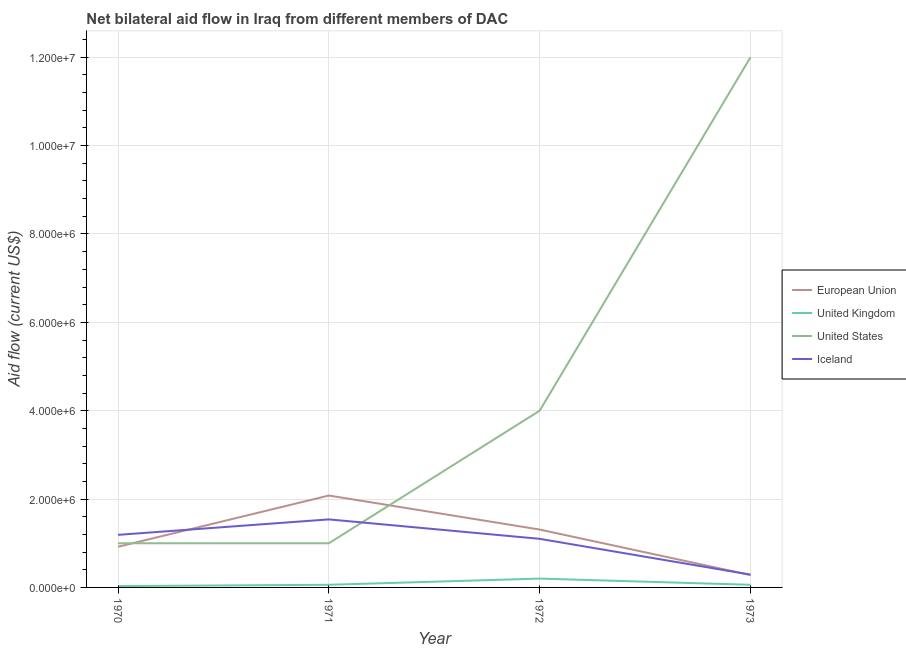Does the line corresponding to amount of aid given by eu intersect with the line corresponding to amount of aid given by uk?
Your answer should be compact. No. What is the amount of aid given by uk in 1971?
Give a very brief answer. 6.00e+04. Across all years, what is the maximum amount of aid given by iceland?
Ensure brevity in your answer.  1.54e+06. Across all years, what is the minimum amount of aid given by iceland?
Ensure brevity in your answer.  2.90e+05. What is the total amount of aid given by eu in the graph?
Your response must be concise. 4.59e+06. What is the difference between the amount of aid given by eu in 1970 and that in 1972?
Provide a short and direct response. -3.90e+05. What is the difference between the amount of aid given by iceland in 1973 and the amount of aid given by us in 1972?
Offer a very short reply. -3.71e+06. What is the average amount of aid given by eu per year?
Your response must be concise. 1.15e+06. In the year 1972, what is the difference between the amount of aid given by eu and amount of aid given by uk?
Offer a terse response. 1.11e+06. What is the ratio of the amount of aid given by us in 1971 to that in 1972?
Your answer should be compact. 0.25. Is the amount of aid given by eu in 1970 less than that in 1971?
Offer a terse response. Yes. Is the difference between the amount of aid given by iceland in 1970 and 1973 greater than the difference between the amount of aid given by eu in 1970 and 1973?
Your answer should be compact. Yes. What is the difference between the highest and the lowest amount of aid given by eu?
Your response must be concise. 1.80e+06. Is it the case that in every year, the sum of the amount of aid given by us and amount of aid given by eu is greater than the sum of amount of aid given by iceland and amount of aid given by uk?
Keep it short and to the point. Yes. Does the amount of aid given by us monotonically increase over the years?
Your answer should be very brief. No. Is the amount of aid given by uk strictly greater than the amount of aid given by eu over the years?
Provide a succinct answer. No. How many years are there in the graph?
Provide a short and direct response. 4. Does the graph contain grids?
Your response must be concise. Yes. How many legend labels are there?
Provide a succinct answer. 4. How are the legend labels stacked?
Give a very brief answer. Vertical. What is the title of the graph?
Make the answer very short. Net bilateral aid flow in Iraq from different members of DAC. What is the label or title of the X-axis?
Your answer should be compact. Year. What is the label or title of the Y-axis?
Ensure brevity in your answer.  Aid flow (current US$). What is the Aid flow (current US$) of European Union in 1970?
Offer a terse response. 9.20e+05. What is the Aid flow (current US$) of United States in 1970?
Offer a terse response. 1.00e+06. What is the Aid flow (current US$) of Iceland in 1970?
Provide a short and direct response. 1.19e+06. What is the Aid flow (current US$) in European Union in 1971?
Ensure brevity in your answer.  2.08e+06. What is the Aid flow (current US$) of United States in 1971?
Keep it short and to the point. 1.00e+06. What is the Aid flow (current US$) in Iceland in 1971?
Provide a short and direct response. 1.54e+06. What is the Aid flow (current US$) in European Union in 1972?
Keep it short and to the point. 1.31e+06. What is the Aid flow (current US$) in United Kingdom in 1972?
Provide a succinct answer. 2.00e+05. What is the Aid flow (current US$) of Iceland in 1972?
Make the answer very short. 1.10e+06. What is the Aid flow (current US$) of European Union in 1973?
Your response must be concise. 2.80e+05. What is the Aid flow (current US$) in United Kingdom in 1973?
Your answer should be compact. 6.00e+04. What is the Aid flow (current US$) of Iceland in 1973?
Provide a succinct answer. 2.90e+05. Across all years, what is the maximum Aid flow (current US$) of European Union?
Ensure brevity in your answer.  2.08e+06. Across all years, what is the maximum Aid flow (current US$) of United Kingdom?
Ensure brevity in your answer.  2.00e+05. Across all years, what is the maximum Aid flow (current US$) of United States?
Your answer should be very brief. 1.20e+07. Across all years, what is the maximum Aid flow (current US$) of Iceland?
Offer a terse response. 1.54e+06. Across all years, what is the minimum Aid flow (current US$) of European Union?
Give a very brief answer. 2.80e+05. Across all years, what is the minimum Aid flow (current US$) in United Kingdom?
Give a very brief answer. 3.00e+04. Across all years, what is the minimum Aid flow (current US$) of Iceland?
Your answer should be compact. 2.90e+05. What is the total Aid flow (current US$) in European Union in the graph?
Your response must be concise. 4.59e+06. What is the total Aid flow (current US$) in United Kingdom in the graph?
Offer a terse response. 3.50e+05. What is the total Aid flow (current US$) of United States in the graph?
Provide a short and direct response. 1.80e+07. What is the total Aid flow (current US$) in Iceland in the graph?
Give a very brief answer. 4.12e+06. What is the difference between the Aid flow (current US$) of European Union in 1970 and that in 1971?
Your answer should be very brief. -1.16e+06. What is the difference between the Aid flow (current US$) of United Kingdom in 1970 and that in 1971?
Ensure brevity in your answer.  -3.00e+04. What is the difference between the Aid flow (current US$) of Iceland in 1970 and that in 1971?
Your answer should be very brief. -3.50e+05. What is the difference between the Aid flow (current US$) of European Union in 1970 and that in 1972?
Give a very brief answer. -3.90e+05. What is the difference between the Aid flow (current US$) of Iceland in 1970 and that in 1972?
Offer a very short reply. 9.00e+04. What is the difference between the Aid flow (current US$) in European Union in 1970 and that in 1973?
Keep it short and to the point. 6.40e+05. What is the difference between the Aid flow (current US$) in United States in 1970 and that in 1973?
Ensure brevity in your answer.  -1.10e+07. What is the difference between the Aid flow (current US$) of Iceland in 1970 and that in 1973?
Keep it short and to the point. 9.00e+05. What is the difference between the Aid flow (current US$) of European Union in 1971 and that in 1972?
Ensure brevity in your answer.  7.70e+05. What is the difference between the Aid flow (current US$) in United States in 1971 and that in 1972?
Provide a succinct answer. -3.00e+06. What is the difference between the Aid flow (current US$) of Iceland in 1971 and that in 1972?
Keep it short and to the point. 4.40e+05. What is the difference between the Aid flow (current US$) in European Union in 1971 and that in 1973?
Your response must be concise. 1.80e+06. What is the difference between the Aid flow (current US$) of United States in 1971 and that in 1973?
Offer a very short reply. -1.10e+07. What is the difference between the Aid flow (current US$) of Iceland in 1971 and that in 1973?
Ensure brevity in your answer.  1.25e+06. What is the difference between the Aid flow (current US$) of European Union in 1972 and that in 1973?
Ensure brevity in your answer.  1.03e+06. What is the difference between the Aid flow (current US$) in United States in 1972 and that in 1973?
Your response must be concise. -8.00e+06. What is the difference between the Aid flow (current US$) in Iceland in 1972 and that in 1973?
Your response must be concise. 8.10e+05. What is the difference between the Aid flow (current US$) of European Union in 1970 and the Aid flow (current US$) of United Kingdom in 1971?
Your response must be concise. 8.60e+05. What is the difference between the Aid flow (current US$) in European Union in 1970 and the Aid flow (current US$) in United States in 1971?
Keep it short and to the point. -8.00e+04. What is the difference between the Aid flow (current US$) in European Union in 1970 and the Aid flow (current US$) in Iceland in 1971?
Offer a terse response. -6.20e+05. What is the difference between the Aid flow (current US$) of United Kingdom in 1970 and the Aid flow (current US$) of United States in 1971?
Ensure brevity in your answer.  -9.70e+05. What is the difference between the Aid flow (current US$) in United Kingdom in 1970 and the Aid flow (current US$) in Iceland in 1971?
Your response must be concise. -1.51e+06. What is the difference between the Aid flow (current US$) of United States in 1970 and the Aid flow (current US$) of Iceland in 1971?
Give a very brief answer. -5.40e+05. What is the difference between the Aid flow (current US$) of European Union in 1970 and the Aid flow (current US$) of United Kingdom in 1972?
Offer a very short reply. 7.20e+05. What is the difference between the Aid flow (current US$) of European Union in 1970 and the Aid flow (current US$) of United States in 1972?
Provide a succinct answer. -3.08e+06. What is the difference between the Aid flow (current US$) of United Kingdom in 1970 and the Aid flow (current US$) of United States in 1972?
Provide a succinct answer. -3.97e+06. What is the difference between the Aid flow (current US$) in United Kingdom in 1970 and the Aid flow (current US$) in Iceland in 1972?
Make the answer very short. -1.07e+06. What is the difference between the Aid flow (current US$) in European Union in 1970 and the Aid flow (current US$) in United Kingdom in 1973?
Provide a short and direct response. 8.60e+05. What is the difference between the Aid flow (current US$) in European Union in 1970 and the Aid flow (current US$) in United States in 1973?
Keep it short and to the point. -1.11e+07. What is the difference between the Aid flow (current US$) of European Union in 1970 and the Aid flow (current US$) of Iceland in 1973?
Give a very brief answer. 6.30e+05. What is the difference between the Aid flow (current US$) of United Kingdom in 1970 and the Aid flow (current US$) of United States in 1973?
Offer a terse response. -1.20e+07. What is the difference between the Aid flow (current US$) of United Kingdom in 1970 and the Aid flow (current US$) of Iceland in 1973?
Offer a terse response. -2.60e+05. What is the difference between the Aid flow (current US$) in United States in 1970 and the Aid flow (current US$) in Iceland in 1973?
Your response must be concise. 7.10e+05. What is the difference between the Aid flow (current US$) in European Union in 1971 and the Aid flow (current US$) in United Kingdom in 1972?
Provide a short and direct response. 1.88e+06. What is the difference between the Aid flow (current US$) in European Union in 1971 and the Aid flow (current US$) in United States in 1972?
Provide a succinct answer. -1.92e+06. What is the difference between the Aid flow (current US$) in European Union in 1971 and the Aid flow (current US$) in Iceland in 1972?
Keep it short and to the point. 9.80e+05. What is the difference between the Aid flow (current US$) in United Kingdom in 1971 and the Aid flow (current US$) in United States in 1972?
Provide a succinct answer. -3.94e+06. What is the difference between the Aid flow (current US$) of United Kingdom in 1971 and the Aid flow (current US$) of Iceland in 1972?
Offer a terse response. -1.04e+06. What is the difference between the Aid flow (current US$) of European Union in 1971 and the Aid flow (current US$) of United Kingdom in 1973?
Your answer should be very brief. 2.02e+06. What is the difference between the Aid flow (current US$) in European Union in 1971 and the Aid flow (current US$) in United States in 1973?
Offer a very short reply. -9.92e+06. What is the difference between the Aid flow (current US$) of European Union in 1971 and the Aid flow (current US$) of Iceland in 1973?
Your answer should be compact. 1.79e+06. What is the difference between the Aid flow (current US$) of United Kingdom in 1971 and the Aid flow (current US$) of United States in 1973?
Offer a very short reply. -1.19e+07. What is the difference between the Aid flow (current US$) in United Kingdom in 1971 and the Aid flow (current US$) in Iceland in 1973?
Provide a succinct answer. -2.30e+05. What is the difference between the Aid flow (current US$) in United States in 1971 and the Aid flow (current US$) in Iceland in 1973?
Ensure brevity in your answer.  7.10e+05. What is the difference between the Aid flow (current US$) of European Union in 1972 and the Aid flow (current US$) of United Kingdom in 1973?
Provide a succinct answer. 1.25e+06. What is the difference between the Aid flow (current US$) of European Union in 1972 and the Aid flow (current US$) of United States in 1973?
Offer a terse response. -1.07e+07. What is the difference between the Aid flow (current US$) of European Union in 1972 and the Aid flow (current US$) of Iceland in 1973?
Give a very brief answer. 1.02e+06. What is the difference between the Aid flow (current US$) of United Kingdom in 1972 and the Aid flow (current US$) of United States in 1973?
Your response must be concise. -1.18e+07. What is the difference between the Aid flow (current US$) in United Kingdom in 1972 and the Aid flow (current US$) in Iceland in 1973?
Ensure brevity in your answer.  -9.00e+04. What is the difference between the Aid flow (current US$) in United States in 1972 and the Aid flow (current US$) in Iceland in 1973?
Provide a short and direct response. 3.71e+06. What is the average Aid flow (current US$) in European Union per year?
Offer a terse response. 1.15e+06. What is the average Aid flow (current US$) in United Kingdom per year?
Provide a short and direct response. 8.75e+04. What is the average Aid flow (current US$) of United States per year?
Provide a succinct answer. 4.50e+06. What is the average Aid flow (current US$) of Iceland per year?
Offer a terse response. 1.03e+06. In the year 1970, what is the difference between the Aid flow (current US$) of European Union and Aid flow (current US$) of United Kingdom?
Your answer should be compact. 8.90e+05. In the year 1970, what is the difference between the Aid flow (current US$) in European Union and Aid flow (current US$) in Iceland?
Provide a short and direct response. -2.70e+05. In the year 1970, what is the difference between the Aid flow (current US$) in United Kingdom and Aid flow (current US$) in United States?
Offer a terse response. -9.70e+05. In the year 1970, what is the difference between the Aid flow (current US$) in United Kingdom and Aid flow (current US$) in Iceland?
Provide a short and direct response. -1.16e+06. In the year 1970, what is the difference between the Aid flow (current US$) of United States and Aid flow (current US$) of Iceland?
Ensure brevity in your answer.  -1.90e+05. In the year 1971, what is the difference between the Aid flow (current US$) in European Union and Aid flow (current US$) in United Kingdom?
Offer a very short reply. 2.02e+06. In the year 1971, what is the difference between the Aid flow (current US$) of European Union and Aid flow (current US$) of United States?
Give a very brief answer. 1.08e+06. In the year 1971, what is the difference between the Aid flow (current US$) in European Union and Aid flow (current US$) in Iceland?
Provide a short and direct response. 5.40e+05. In the year 1971, what is the difference between the Aid flow (current US$) of United Kingdom and Aid flow (current US$) of United States?
Offer a very short reply. -9.40e+05. In the year 1971, what is the difference between the Aid flow (current US$) in United Kingdom and Aid flow (current US$) in Iceland?
Your response must be concise. -1.48e+06. In the year 1971, what is the difference between the Aid flow (current US$) in United States and Aid flow (current US$) in Iceland?
Keep it short and to the point. -5.40e+05. In the year 1972, what is the difference between the Aid flow (current US$) in European Union and Aid flow (current US$) in United Kingdom?
Provide a succinct answer. 1.11e+06. In the year 1972, what is the difference between the Aid flow (current US$) in European Union and Aid flow (current US$) in United States?
Offer a terse response. -2.69e+06. In the year 1972, what is the difference between the Aid flow (current US$) of United Kingdom and Aid flow (current US$) of United States?
Make the answer very short. -3.80e+06. In the year 1972, what is the difference between the Aid flow (current US$) in United Kingdom and Aid flow (current US$) in Iceland?
Ensure brevity in your answer.  -9.00e+05. In the year 1972, what is the difference between the Aid flow (current US$) of United States and Aid flow (current US$) of Iceland?
Make the answer very short. 2.90e+06. In the year 1973, what is the difference between the Aid flow (current US$) of European Union and Aid flow (current US$) of United Kingdom?
Make the answer very short. 2.20e+05. In the year 1973, what is the difference between the Aid flow (current US$) in European Union and Aid flow (current US$) in United States?
Keep it short and to the point. -1.17e+07. In the year 1973, what is the difference between the Aid flow (current US$) in European Union and Aid flow (current US$) in Iceland?
Your answer should be very brief. -10000. In the year 1973, what is the difference between the Aid flow (current US$) of United Kingdom and Aid flow (current US$) of United States?
Keep it short and to the point. -1.19e+07. In the year 1973, what is the difference between the Aid flow (current US$) of United Kingdom and Aid flow (current US$) of Iceland?
Give a very brief answer. -2.30e+05. In the year 1973, what is the difference between the Aid flow (current US$) of United States and Aid flow (current US$) of Iceland?
Your answer should be very brief. 1.17e+07. What is the ratio of the Aid flow (current US$) of European Union in 1970 to that in 1971?
Provide a short and direct response. 0.44. What is the ratio of the Aid flow (current US$) in Iceland in 1970 to that in 1971?
Your answer should be very brief. 0.77. What is the ratio of the Aid flow (current US$) in European Union in 1970 to that in 1972?
Your answer should be very brief. 0.7. What is the ratio of the Aid flow (current US$) of Iceland in 1970 to that in 1972?
Offer a terse response. 1.08. What is the ratio of the Aid flow (current US$) in European Union in 1970 to that in 1973?
Offer a terse response. 3.29. What is the ratio of the Aid flow (current US$) in United States in 1970 to that in 1973?
Make the answer very short. 0.08. What is the ratio of the Aid flow (current US$) in Iceland in 1970 to that in 1973?
Offer a very short reply. 4.1. What is the ratio of the Aid flow (current US$) in European Union in 1971 to that in 1972?
Give a very brief answer. 1.59. What is the ratio of the Aid flow (current US$) in United Kingdom in 1971 to that in 1972?
Your answer should be very brief. 0.3. What is the ratio of the Aid flow (current US$) of United States in 1971 to that in 1972?
Provide a short and direct response. 0.25. What is the ratio of the Aid flow (current US$) of European Union in 1971 to that in 1973?
Ensure brevity in your answer.  7.43. What is the ratio of the Aid flow (current US$) in United States in 1971 to that in 1973?
Give a very brief answer. 0.08. What is the ratio of the Aid flow (current US$) of Iceland in 1971 to that in 1973?
Offer a terse response. 5.31. What is the ratio of the Aid flow (current US$) in European Union in 1972 to that in 1973?
Your answer should be very brief. 4.68. What is the ratio of the Aid flow (current US$) in United States in 1972 to that in 1973?
Provide a short and direct response. 0.33. What is the ratio of the Aid flow (current US$) in Iceland in 1972 to that in 1973?
Your answer should be compact. 3.79. What is the difference between the highest and the second highest Aid flow (current US$) in European Union?
Offer a terse response. 7.70e+05. What is the difference between the highest and the second highest Aid flow (current US$) of United Kingdom?
Provide a succinct answer. 1.40e+05. What is the difference between the highest and the second highest Aid flow (current US$) of Iceland?
Offer a terse response. 3.50e+05. What is the difference between the highest and the lowest Aid flow (current US$) in European Union?
Your answer should be compact. 1.80e+06. What is the difference between the highest and the lowest Aid flow (current US$) in United Kingdom?
Your answer should be compact. 1.70e+05. What is the difference between the highest and the lowest Aid flow (current US$) in United States?
Your answer should be compact. 1.10e+07. What is the difference between the highest and the lowest Aid flow (current US$) in Iceland?
Ensure brevity in your answer.  1.25e+06. 